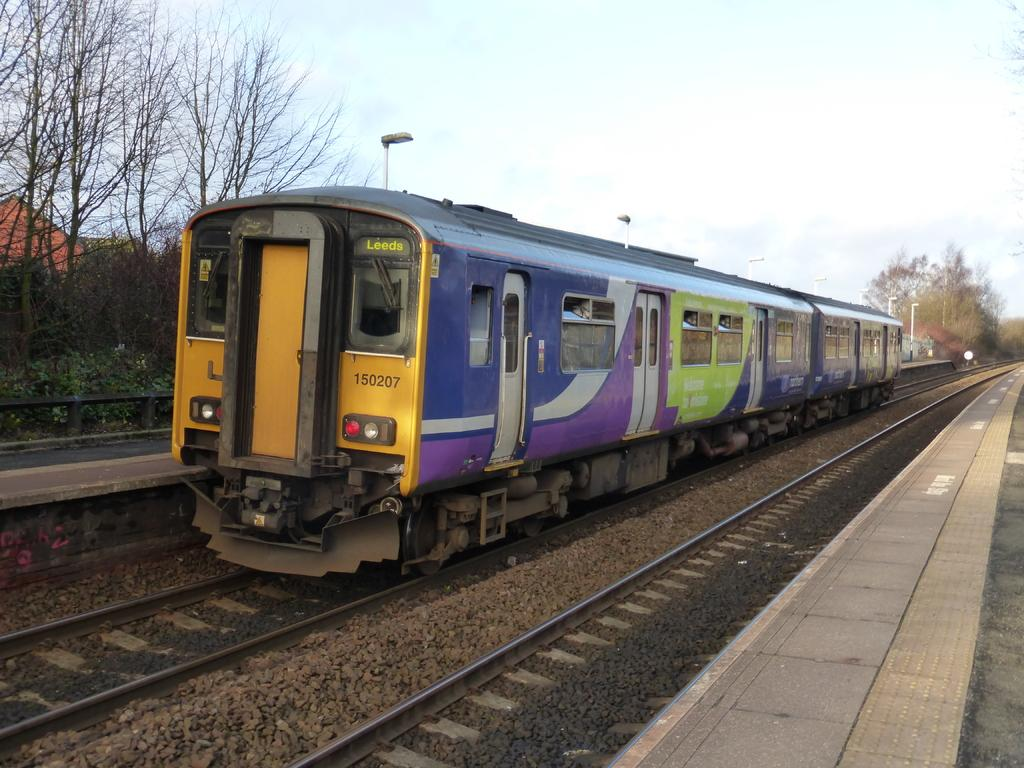What is the main subject of the image? The main subject of the image is a train on the track. What other elements can be seen in the image besides the train? There are plants, trees, poles, and the sky visible in the image. Can you describe the vegetation in the image? The image features both plants and trees. What is visible in the background of the image? The sky is visible in the background of the image. What type of tax is being discussed in the image? There is no discussion of tax in the image; it features a train on the track and other elements. Can you tell me how many horses are present in the image? There are no horses present in the image. 